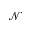<formula> <loc_0><loc_0><loc_500><loc_500>\mathcal { N }</formula> 